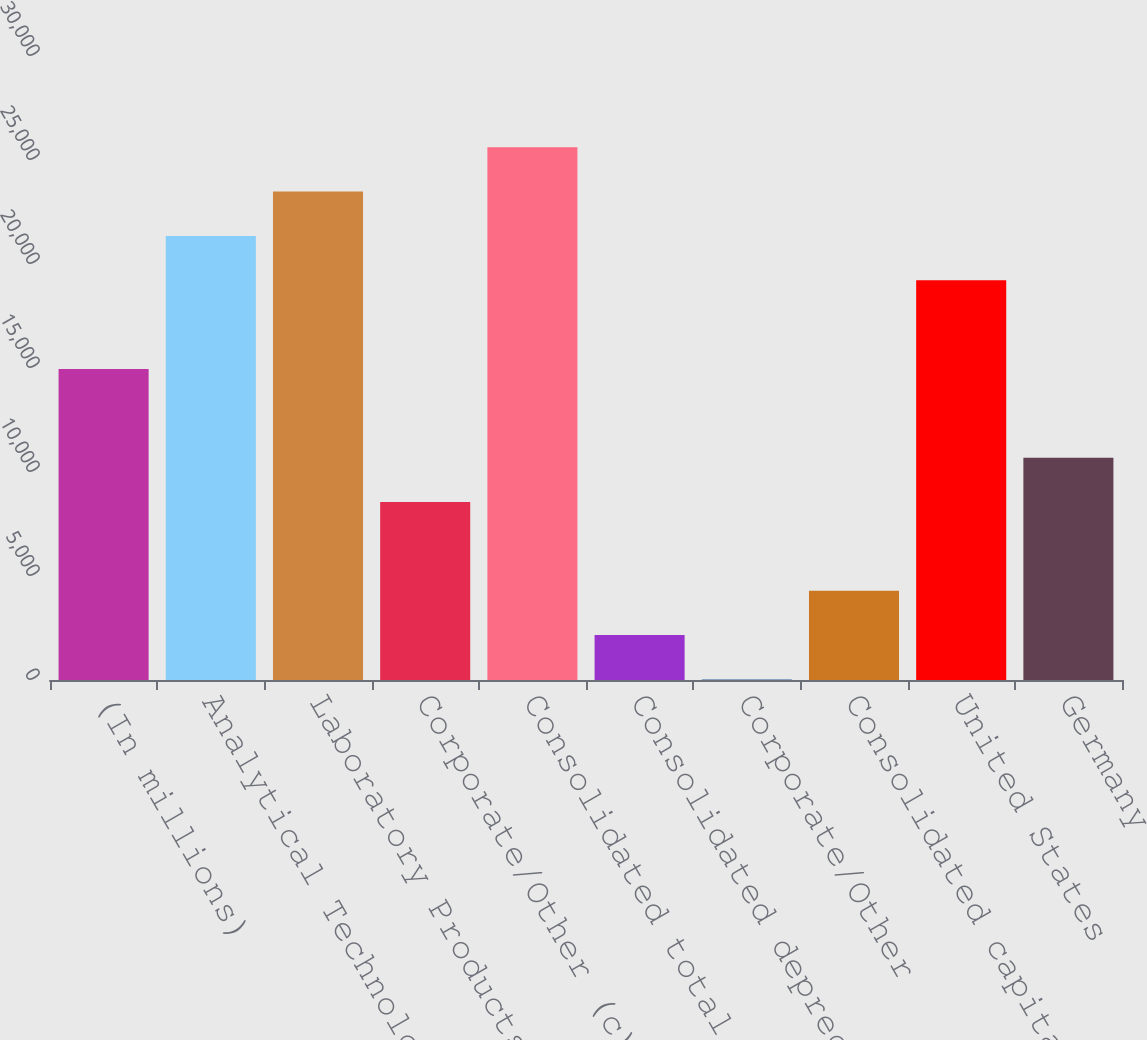<chart> <loc_0><loc_0><loc_500><loc_500><bar_chart><fcel>(In millions)<fcel>Analytical Technologies<fcel>Laboratory Products and<fcel>Corporate/Other (c)<fcel>Consolidated total assets<fcel>Consolidated depreciation<fcel>Corporate/Other<fcel>Consolidated capital<fcel>United States<fcel>Germany<nl><fcel>14952.3<fcel>21349.4<fcel>23481.8<fcel>8555.12<fcel>25614.2<fcel>2157.98<fcel>25.6<fcel>4290.36<fcel>19217<fcel>10687.5<nl></chart> 